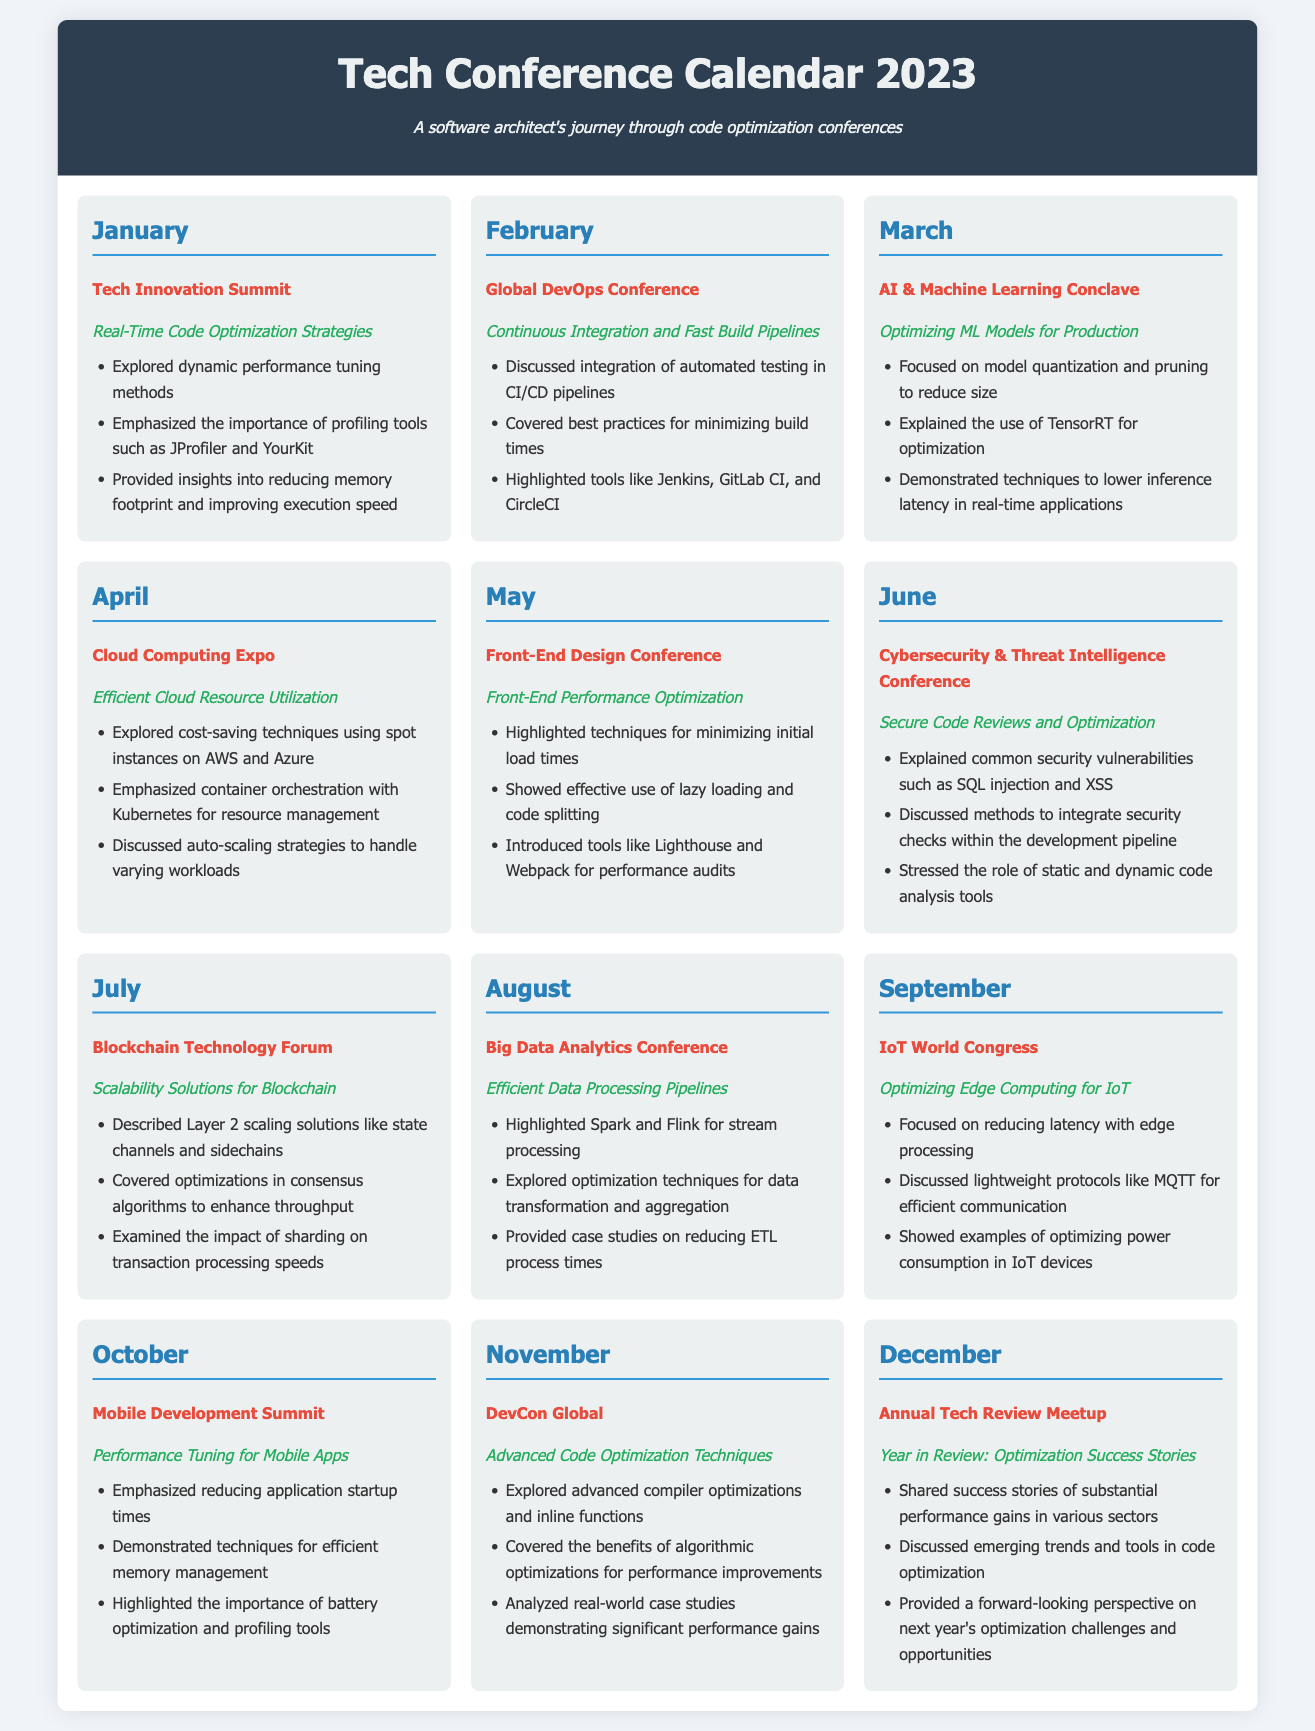What is the title of the conference in January? The title of the conference for January is listed in the document under that month.
Answer: Tech Innovation Summit What session highlight is mentioned for February? The session highlight for February is provided in the document under the Global DevOps Conference.
Answer: Continuous Integration and Fast Build Pipelines Which month features a conference on optimizing ML models? The month featuring a conference on optimizing ML models is specified in the document.
Answer: March How many sessions are highlighted in the October conference? The number of sessions highlighted is found in the list under the Mobile Development Summit.
Answer: Three What is the main focus of the June conference? The focus of the June conference can be found in the description provided under that month.
Answer: Secure Code Reviews and Optimization Which tools are highlighted in the May conference? The tools mentioned for the May conference are listed under the Front-End Design Conference section.
Answer: Lighthouse and Webpack What is the theme of the December conference? The theme for the December conference is indicated in the document under the Annual Tech Review Meetup.
Answer: Year in Review: Optimization Success Stories Which month discusses container orchestration? The month that discusses container orchestration is specified in the document.
Answer: April What optimization technique is highlighted for IoT devices in September? The optimization technique for IoT devices is mentioned in the description for that month.
Answer: Optimizing power consumption 